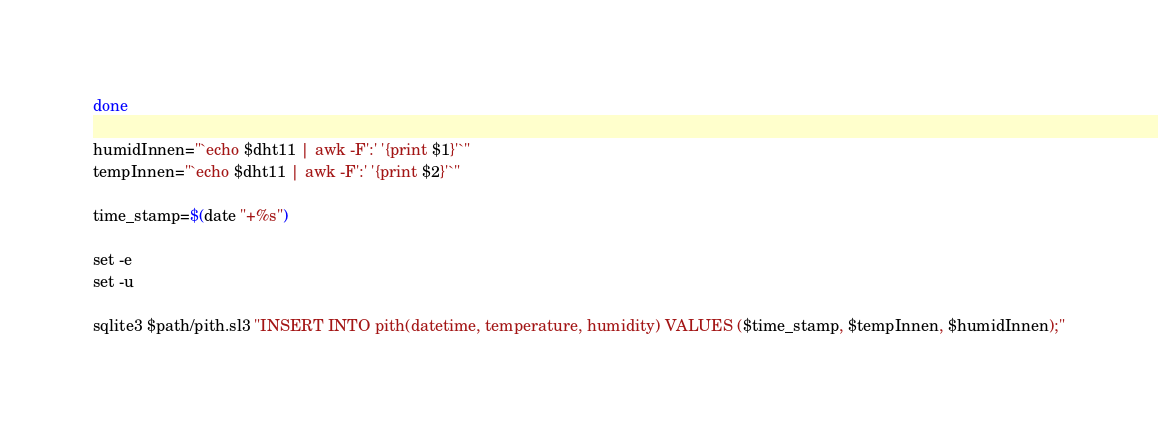<code> <loc_0><loc_0><loc_500><loc_500><_Bash_>done
 
humidInnen="`echo $dht11 | awk -F':' '{print $1}'`"
tempInnen="`echo $dht11 | awk -F':' '{print $2}'`"

time_stamp=$(date "+%s")

set -e
set -u

sqlite3 $path/pith.sl3 "INSERT INTO pith(datetime, temperature, humidity) VALUES ($time_stamp, $tempInnen, $humidInnen);"

</code> 